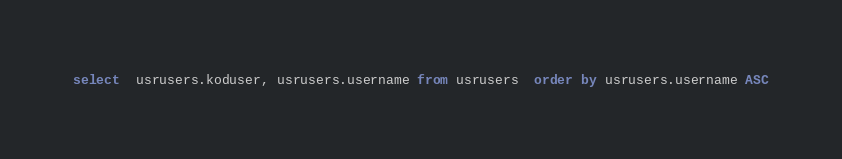Convert code to text. <code><loc_0><loc_0><loc_500><loc_500><_SQL_>select  usrusers.koduser, usrusers.username from usrusers  order by usrusers.username ASC</code> 